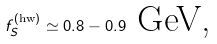Convert formula to latex. <formula><loc_0><loc_0><loc_500><loc_500>f _ { S } ^ { \left ( \text {hw} \right ) } \simeq 0 . 8 - 0 . 9 \text { GeV,}</formula> 